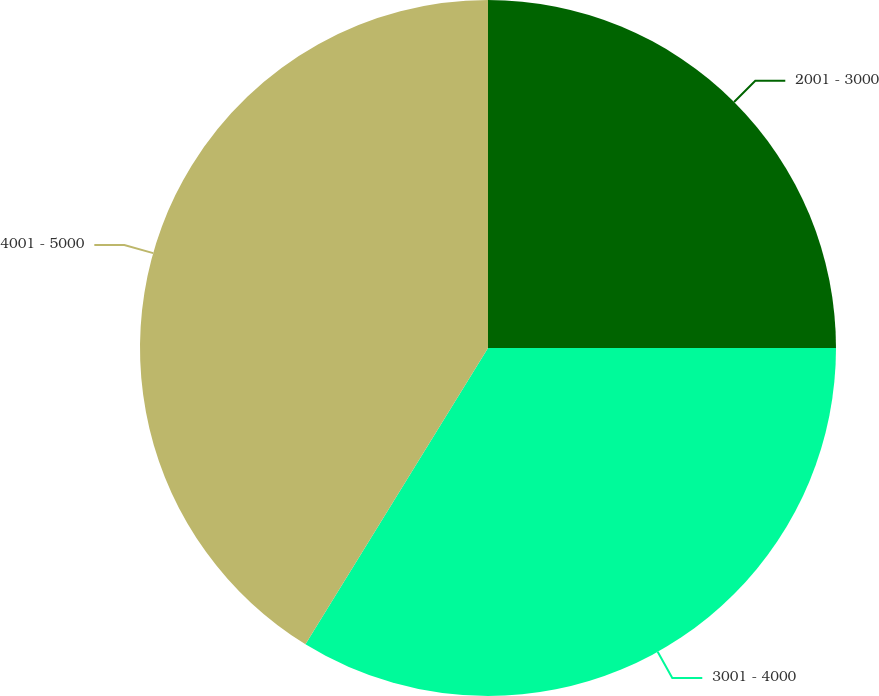Convert chart. <chart><loc_0><loc_0><loc_500><loc_500><pie_chart><fcel>2001 - 3000<fcel>3001 - 4000<fcel>4001 - 5000<nl><fcel>25.0%<fcel>33.79%<fcel>41.21%<nl></chart> 